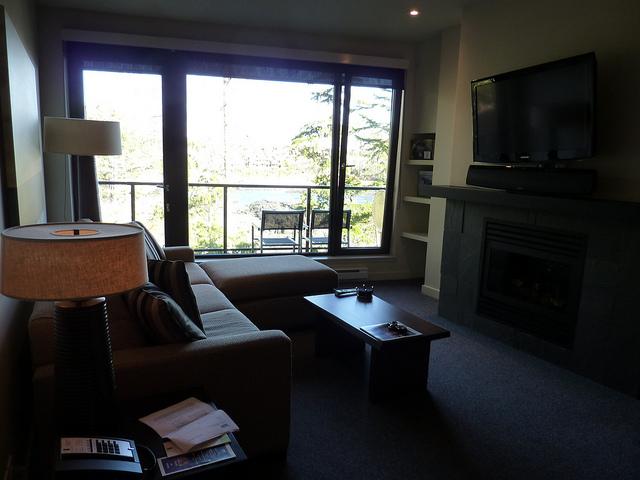What color is the lamp shade?
Answer briefly. White. What room is this?
Concise answer only. Living room. How many pillows are on the sofa?
Concise answer only. 2. What time of day is this?
Be succinct. Afternoon. What is on the window sill?
Quick response, please. Nothing. How many lamps are in this room?
Answer briefly. 2. 